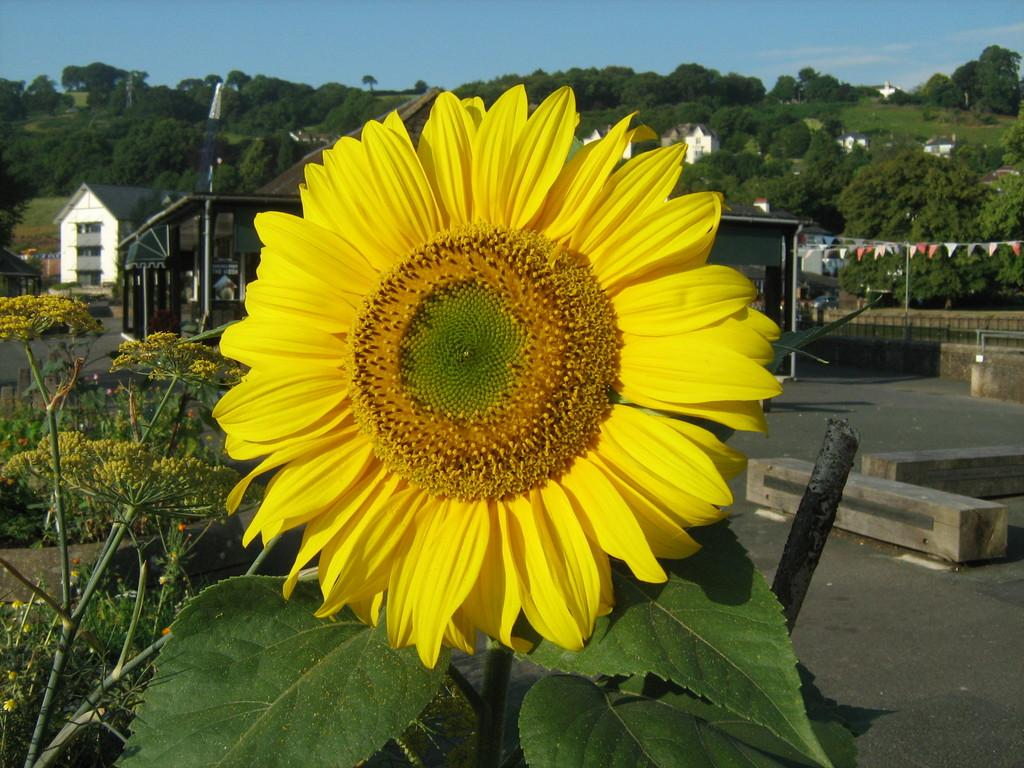What type of plant is in the image? There is a sunflower in the image. What type of structures are in the image? There are houses in the image. What other natural elements are in the image? There are trees in the image. What else is visible in the image? There are flags in the image. What can be seen in the background of the image? The sky with clouds is visible in the background of the image. What type of roof can be seen on the sunflower in the image? There is no roof present on the sunflower in the image, as it is a plant and not a structure. 